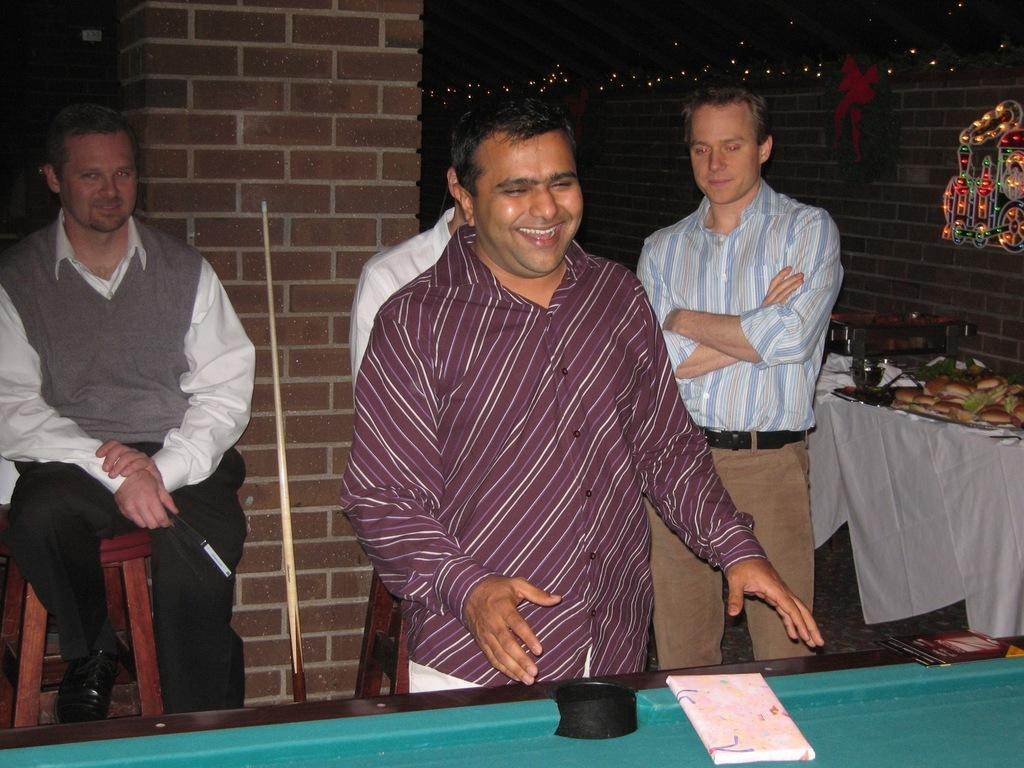How many people are in the image? There is a group of people in the image, but the exact number cannot be determined from the provided facts. What is the man in the image doing? The man is seated on a chair in the image. What is on the table in the image? There is a table in the image, and there is food on the table. Where is the sink located in the image? There is no sink present in the image. What type of brush is being used by the people in the image? There is no brush visible in the image. 